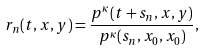<formula> <loc_0><loc_0><loc_500><loc_500>r _ { n } ( t , x , y ) = \frac { p ^ { \kappa } ( t + s _ { n } , x , y ) } { p ^ { \kappa } ( s _ { n } , x _ { 0 } , x _ { 0 } ) } ,</formula> 